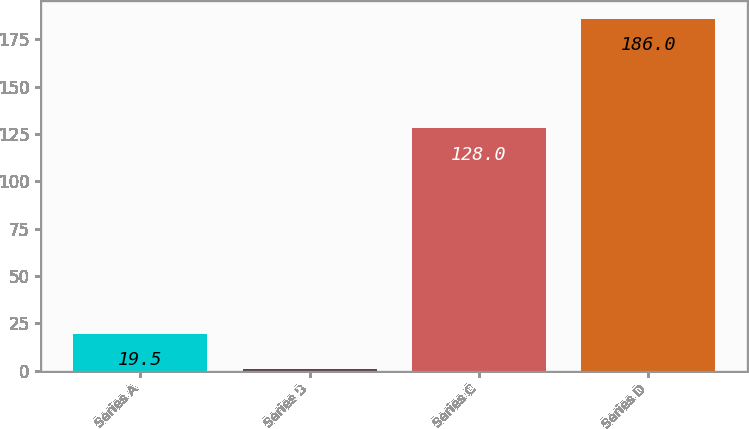Convert chart to OTSL. <chart><loc_0><loc_0><loc_500><loc_500><bar_chart><fcel>Series A<fcel>Series B<fcel>Series C<fcel>Series D<nl><fcel>19.5<fcel>1<fcel>128<fcel>186<nl></chart> 